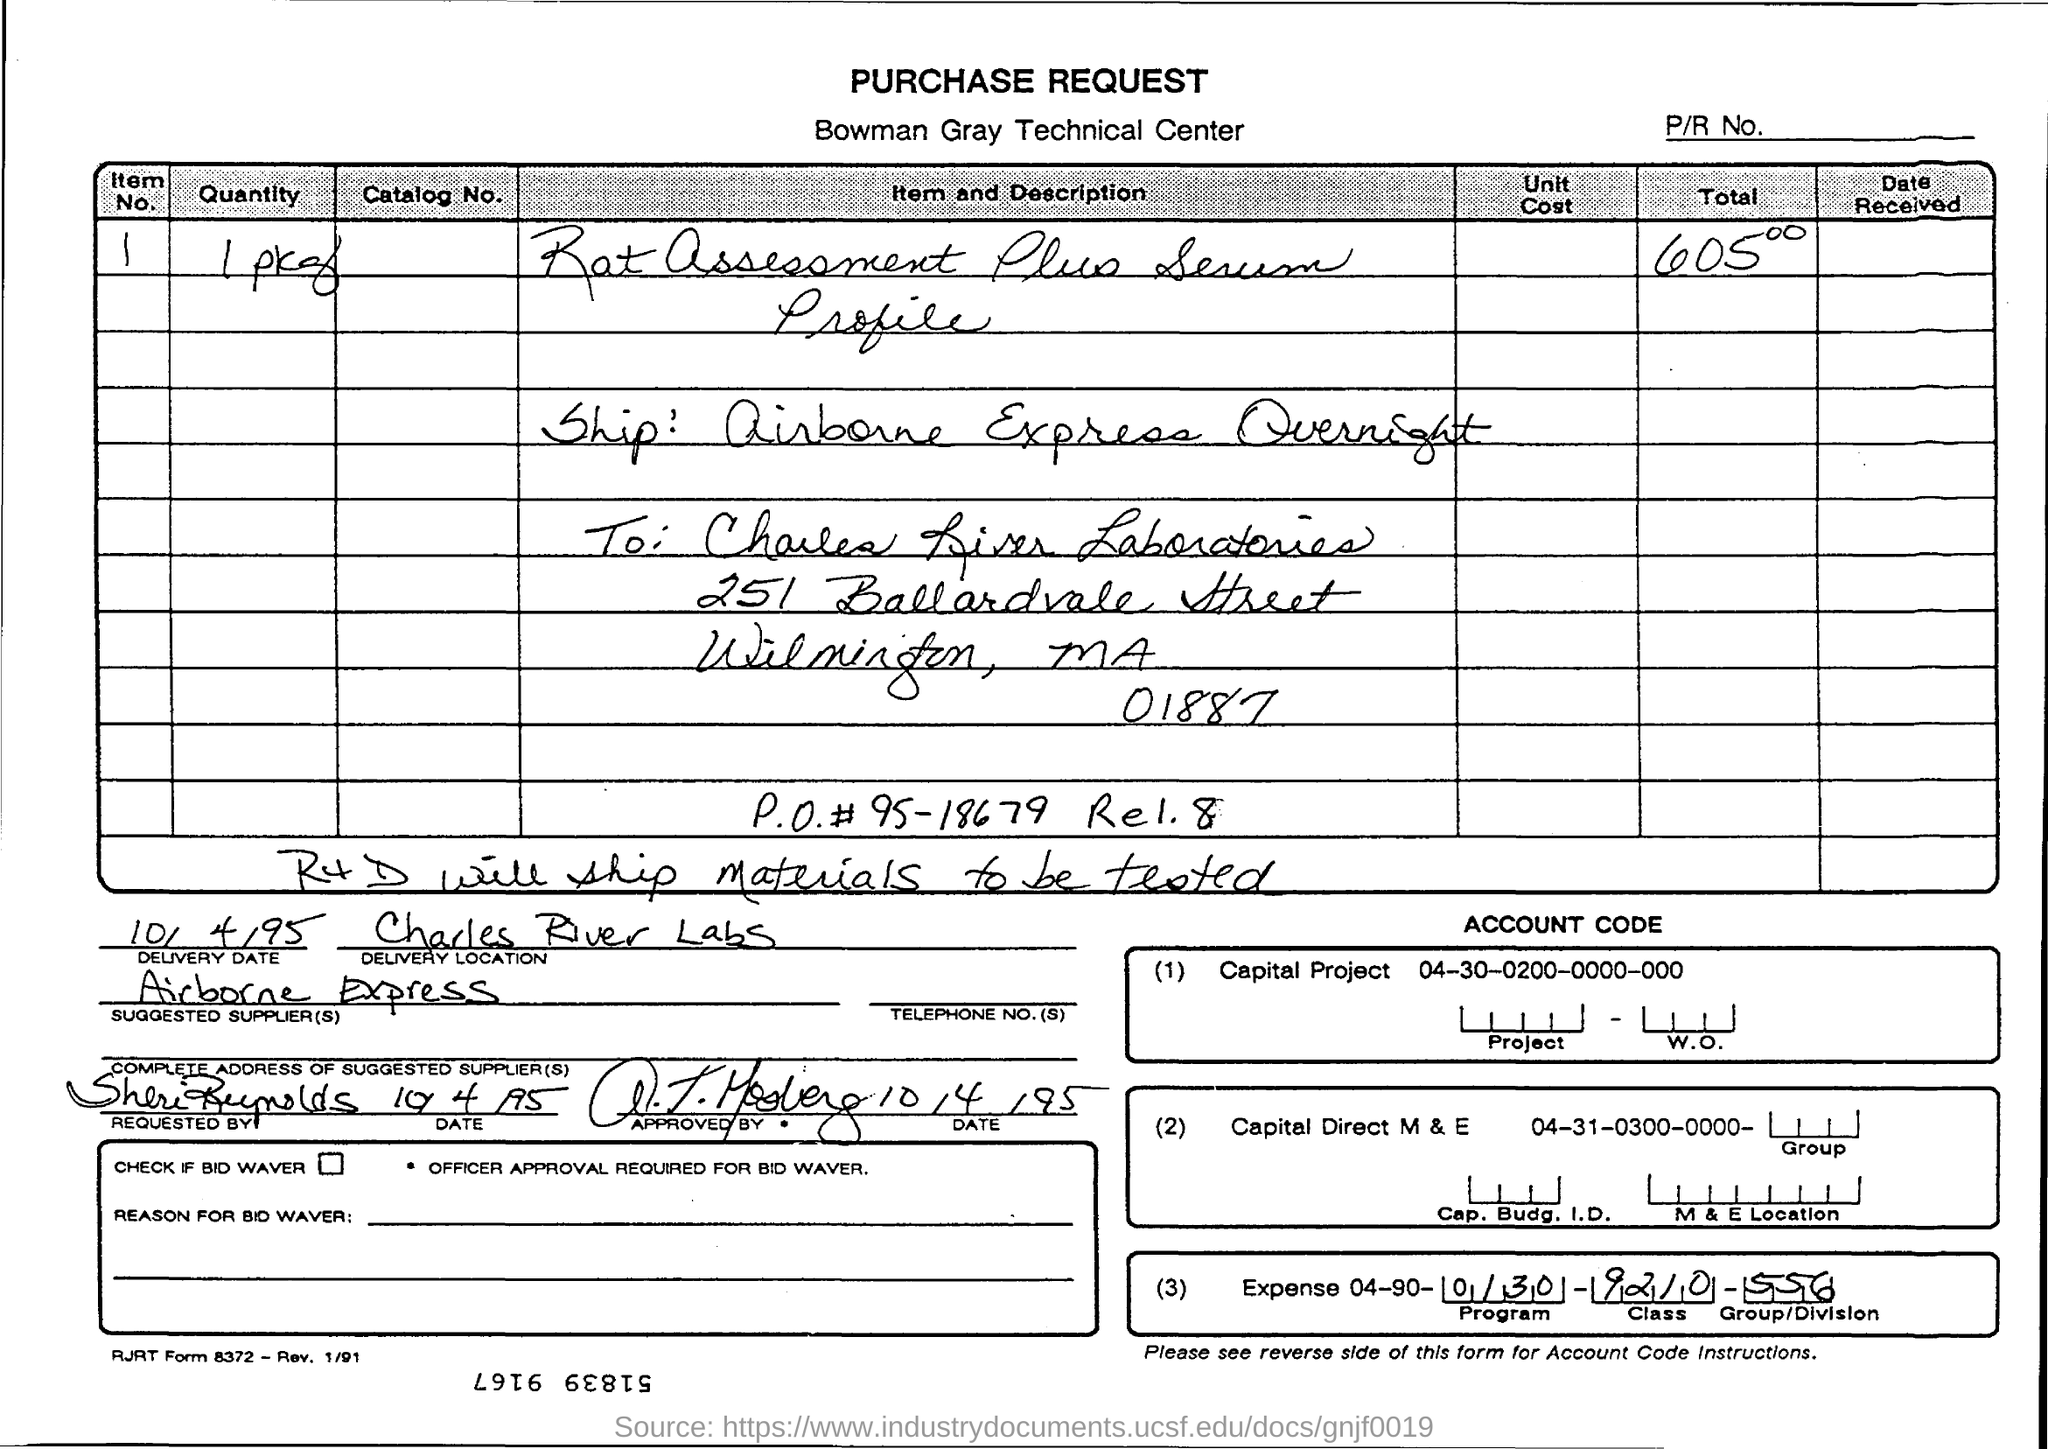Give some essential details in this illustration. The name of the Bowman Gray Technical Center is [the Bowman Gray Technical Center]. 